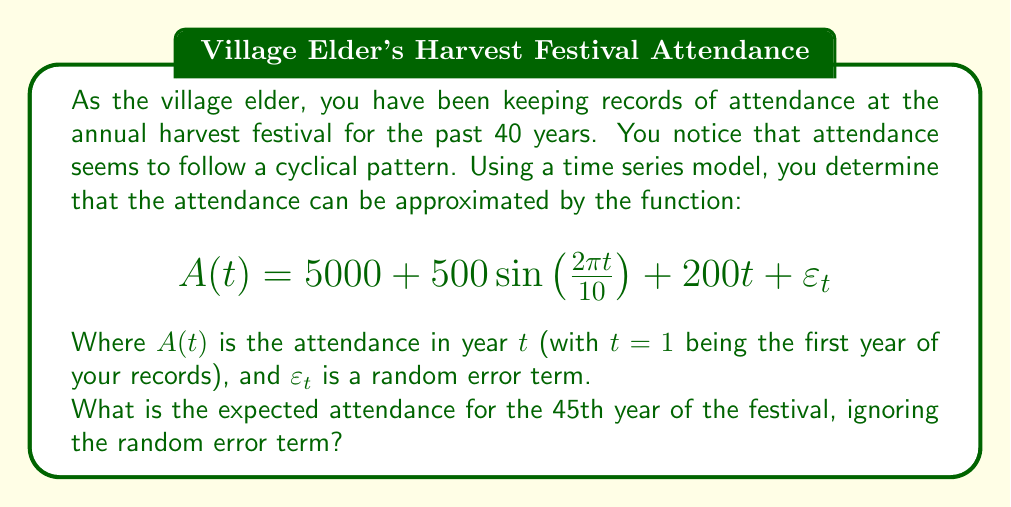Teach me how to tackle this problem. To solve this problem, we need to follow these steps:

1) Understand the components of the time series model:
   - $5000$ is the base attendance
   - $500\sin\left(\frac{2\pi t}{10}\right)$ represents the cyclical component with a 10-year period
   - $200t$ represents the linear trend
   - $\varepsilon_t$ is the random error term (which we'll ignore as per the question)

2) We need to calculate the attendance for $t=45$ (the 45th year):

   $$A(45) = 5000 + 500\sin\left(\frac{2\pi (45)}{10}\right) + 200(45)$$

3) Let's break this down further:
   
   a) The base attendance is 5000

   b) For the cyclical component:
      $$500\sin\left(\frac{2\pi (45)}{10}\right) = 500\sin(9\pi) = 0$$
      (since $\sin(9\pi) = \sin(\pi) = 0$)

   c) For the linear trend:
      $$200(45) = 9000$$

4) Now, we can sum up all components:
   $$A(45) = 5000 + 0 + 9000 = 14000$$

Therefore, the expected attendance for the 45th year of the festival is 14,000 people.
Answer: 14,000 people 